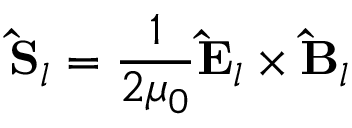Convert formula to latex. <formula><loc_0><loc_0><loc_500><loc_500>\hat { S } _ { l } = \frac { 1 } { 2 \mu _ { 0 } } \hat { E } _ { l } \times \hat { B } _ { l }</formula> 